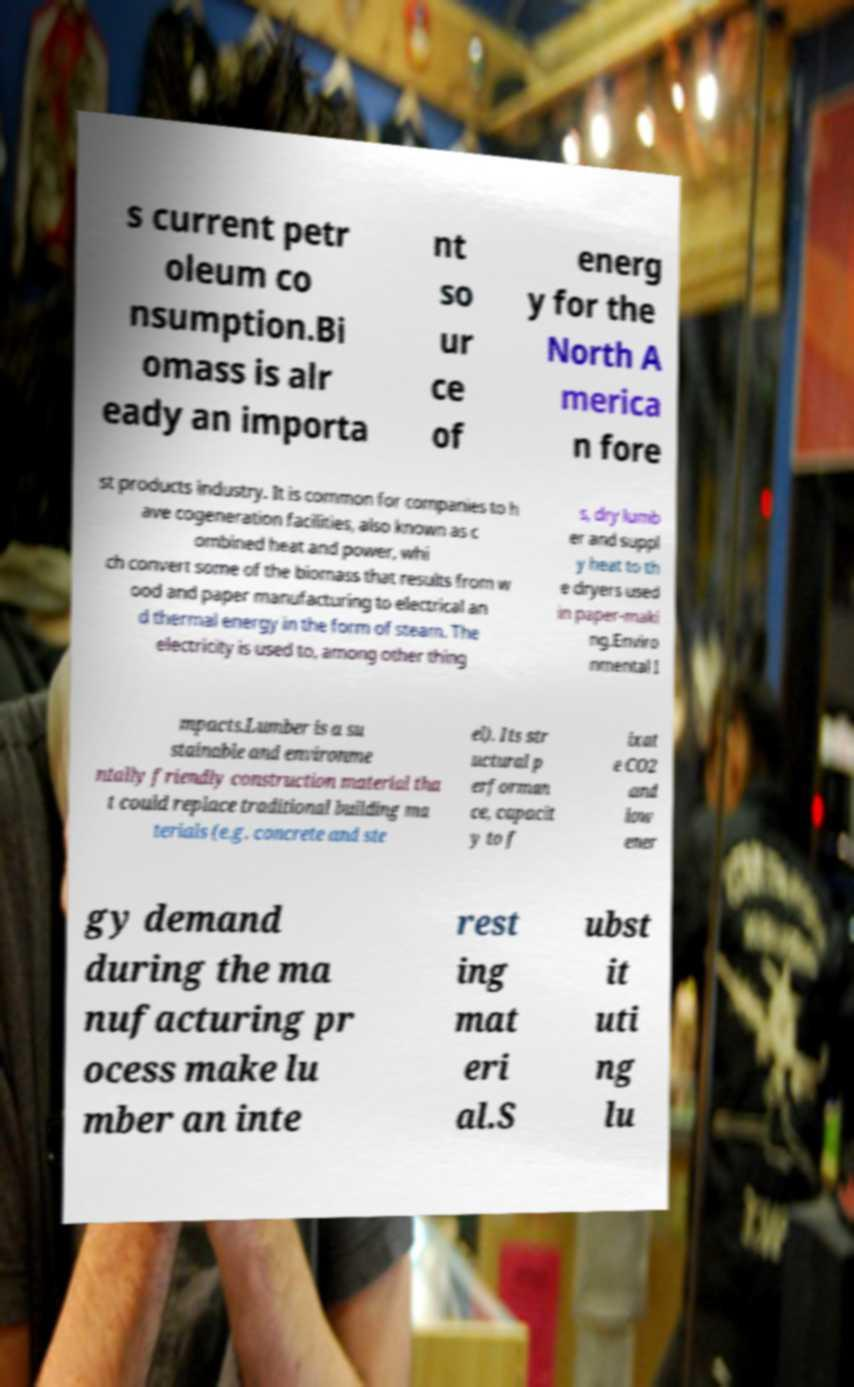Could you extract and type out the text from this image? s current petr oleum co nsumption.Bi omass is alr eady an importa nt so ur ce of energ y for the North A merica n fore st products industry. It is common for companies to h ave cogeneration facilities, also known as c ombined heat and power, whi ch convert some of the biomass that results from w ood and paper manufacturing to electrical an d thermal energy in the form of steam. The electricity is used to, among other thing s, dry lumb er and suppl y heat to th e dryers used in paper-maki ng.Enviro nmental I mpacts.Lumber is a su stainable and environme ntally friendly construction material tha t could replace traditional building ma terials (e.g. concrete and ste el). Its str uctural p erforman ce, capacit y to f ixat e CO2 and low ener gy demand during the ma nufacturing pr ocess make lu mber an inte rest ing mat eri al.S ubst it uti ng lu 